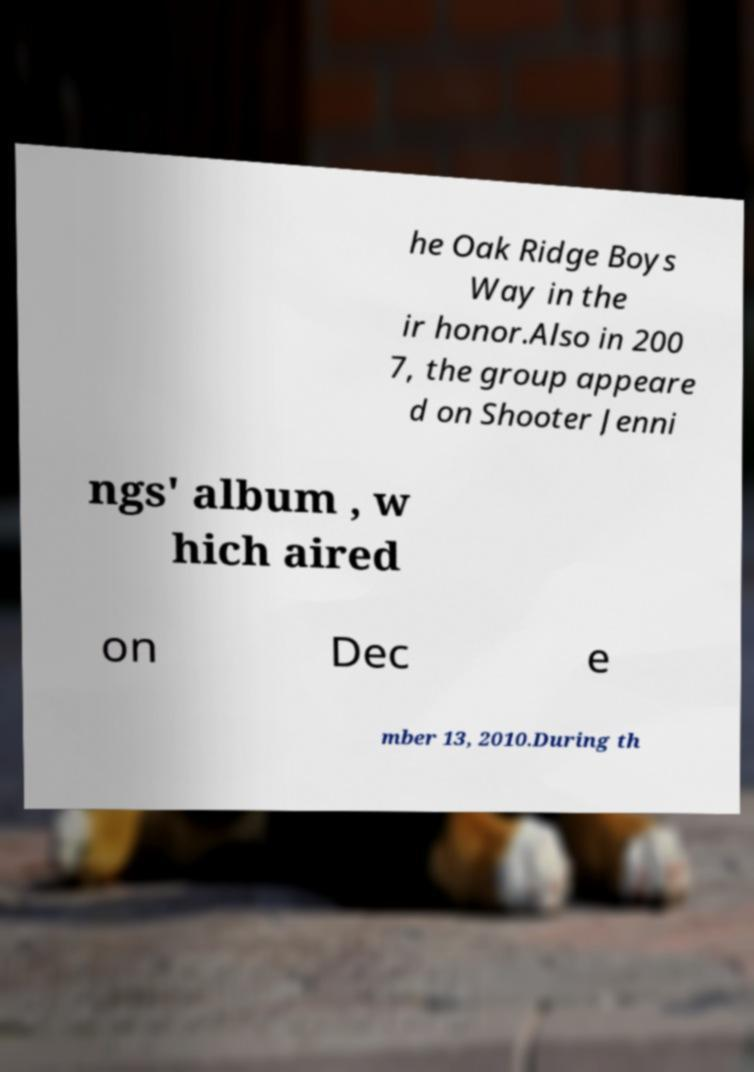For documentation purposes, I need the text within this image transcribed. Could you provide that? he Oak Ridge Boys Way in the ir honor.Also in 200 7, the group appeare d on Shooter Jenni ngs' album , w hich aired on Dec e mber 13, 2010.During th 